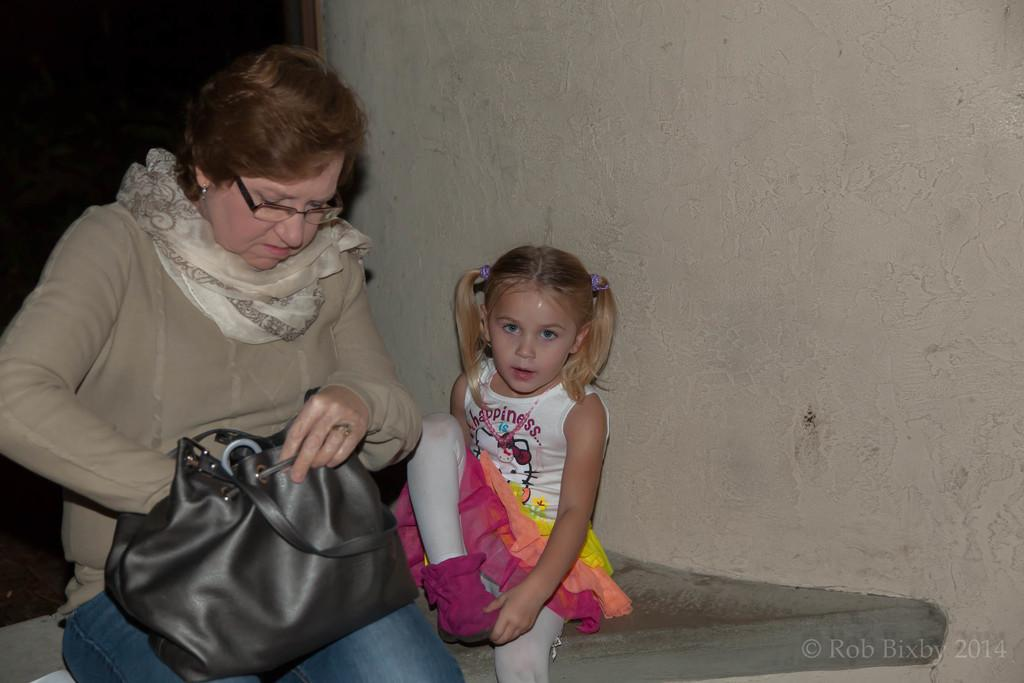Who are the people in the image? There is a mom and a daughter in the image. What is the mom doing with the bag? The mom is holding a bag and checking it. What can be seen in the background of the image? There is a wall and a door in the background of the image. What arithmetic problem is the mom solving in the image? There is no arithmetic problem visible in the image. What color is the mom's shirt in the image? The provided facts do not mention the color of the mom's shirt, so we cannot determine that information from the image. 